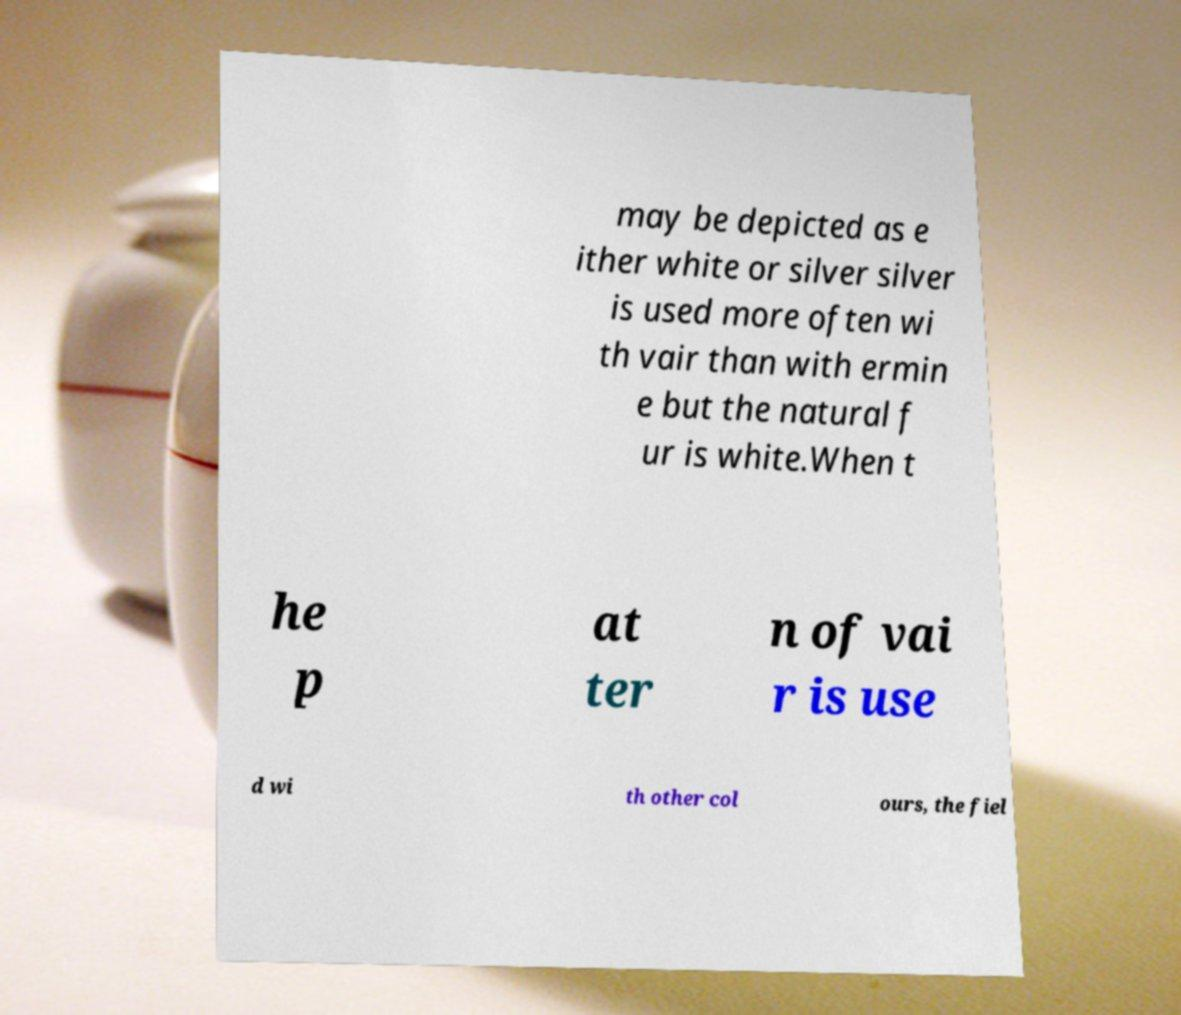There's text embedded in this image that I need extracted. Can you transcribe it verbatim? may be depicted as e ither white or silver silver is used more often wi th vair than with ermin e but the natural f ur is white.When t he p at ter n of vai r is use d wi th other col ours, the fiel 